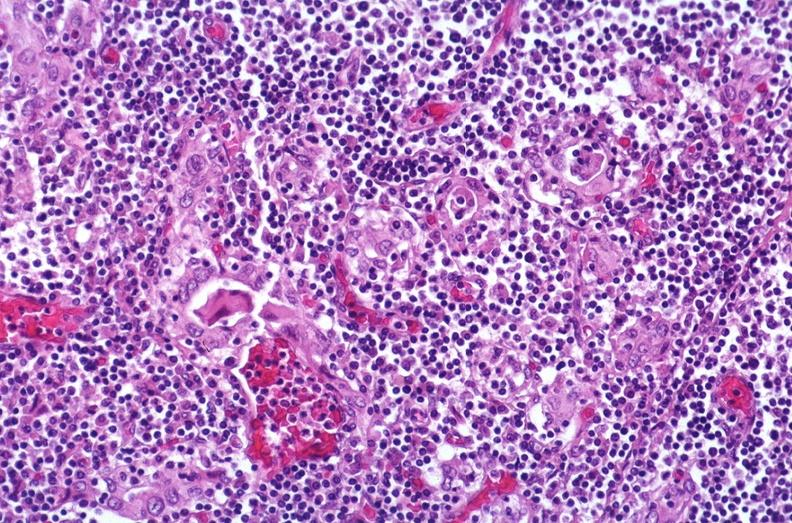does typical tuberculous exudate show hashimoto 's thyroiditis?
Answer the question using a single word or phrase. No 